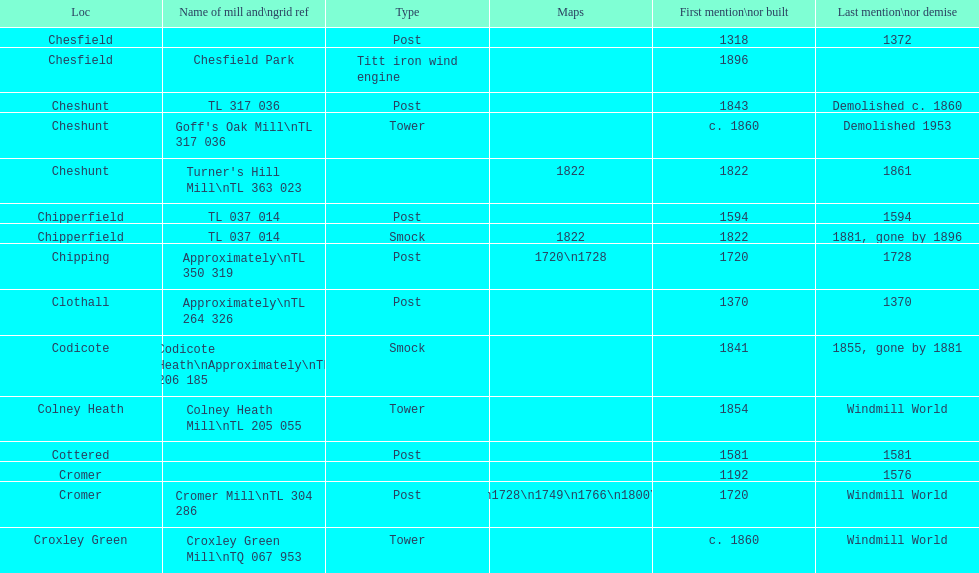What is the aggregate number of mills named cheshunt? 3. 